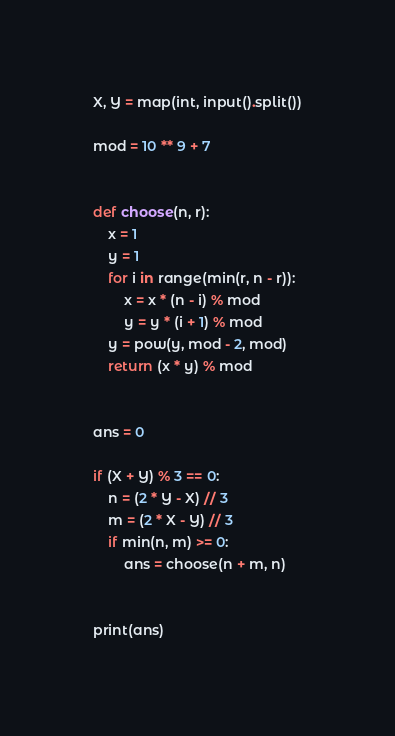<code> <loc_0><loc_0><loc_500><loc_500><_Python_>X, Y = map(int, input().split())

mod = 10 ** 9 + 7


def choose(n, r):
    x = 1
    y = 1
    for i in range(min(r, n - r)):
        x = x * (n - i) % mod
        y = y * (i + 1) % mod
    y = pow(y, mod - 2, mod)
    return (x * y) % mod


ans = 0

if (X + Y) % 3 == 0:
    n = (2 * Y - X) // 3
    m = (2 * X - Y) // 3
    if min(n, m) >= 0:
        ans = choose(n + m, n)


print(ans)
</code> 